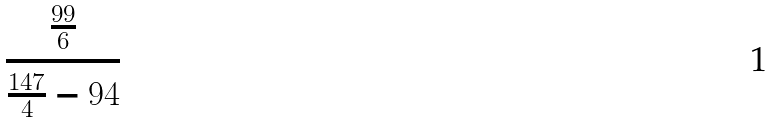Convert formula to latex. <formula><loc_0><loc_0><loc_500><loc_500>\frac { \frac { 9 9 } { 6 } } { \frac { 1 4 7 } { 4 } - 9 4 }</formula> 